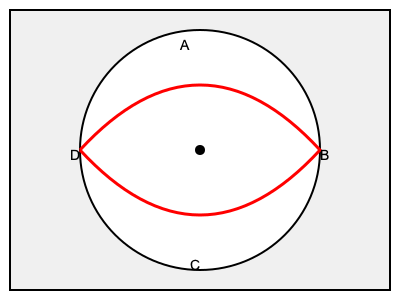In this diagram of a 1930s baseball, which letter represents the area where the signature of the league president would typically be found? To answer this question, we need to consider the structure of a 1930s baseball:

1. The baseball is divided into two main sections: the cover and the stitching.
2. The cover is made of horsehide or cowhide and consists of two pieces shaped like figure-eights.
3. The stitching, represented by the red line in the diagram, holds these two pieces together.
4. In the 1930s, baseballs used in professional leagues had specific areas for different markings:
   a) The league president's signature was typically stamped on one of the panels between the stitching.
   b) The manufacturer's name was usually on the opposite panel.
   c) The league name was often stamped below the manufacturer's name.

5. Looking at the diagram:
   - A is at the top of the ball, which is not a typical location for signatures.
   - B and D are on the stitching, where signatures are not placed.
   - C is on one of the leather panels between the stitching.

6. Therefore, C represents the most likely area where the league president's signature would be found on a 1930s baseball.
Answer: C 